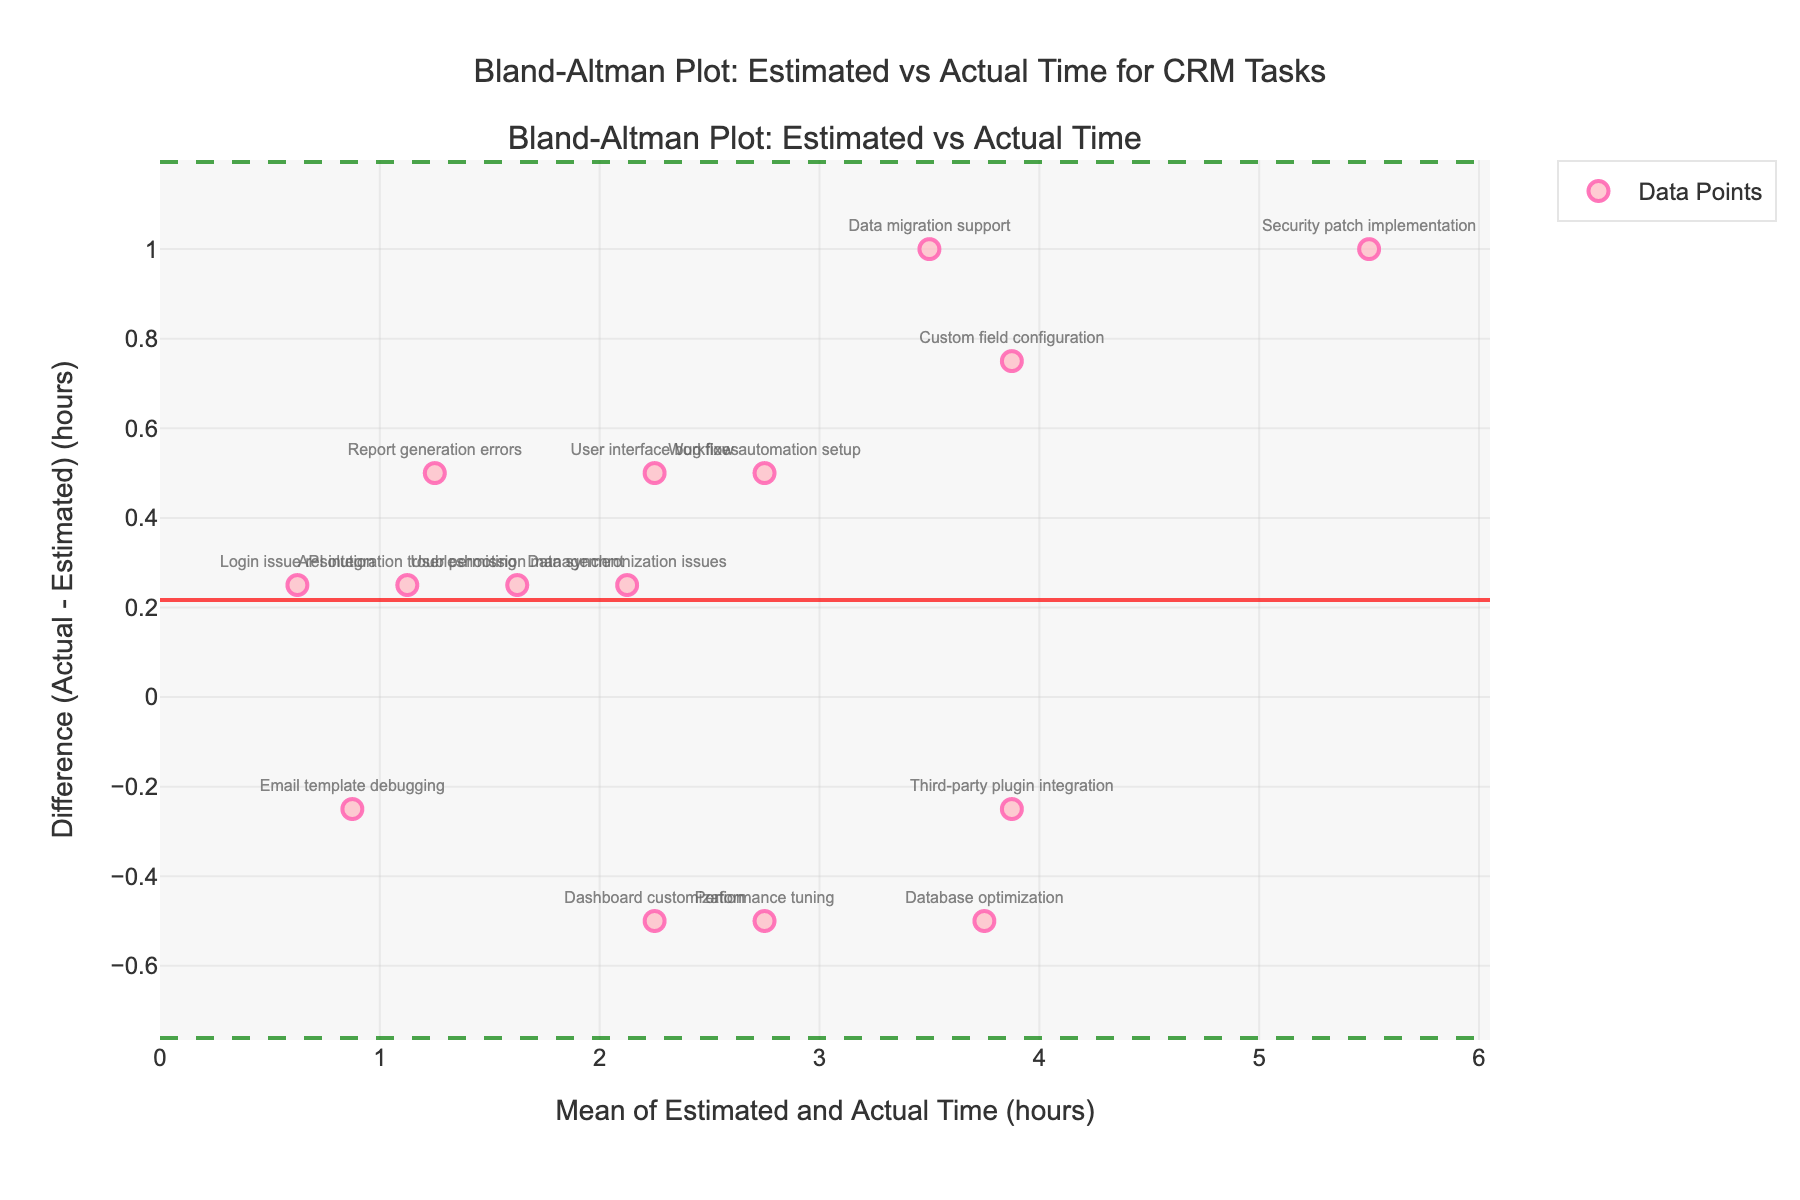What is the title of the figure? The title of the figure is generally found at the top and describes the content of the plot. Here, it is displayed clearly.
Answer: Bland-Altman Plot: Estimated vs Actual Time How many data points are represented in the plot? This can be observed by counting the number of markers on the plot. Each marker represents one data point.
Answer: 15 What do the horizontal lines on the plot represent? There are three horizontal lines that represent different statistical measurements. The solid red line represents the mean difference, while the dashed green lines represent the upper and lower limits of agreement.
Answer: Mean difference and limits of agreement What is the approximate mean difference (Actual - Estimated) based on the plot? The mean difference is represented by the solid red horizontal line on the plot. By looking at the y-axis value where this line is placed, we can approximate it.
Answer: Around 0.46 hours Which task has the largest positive difference between Actual and Estimated time? Identify which marker is highest above the mean difference line. By hovering or looking at the label near this marker, we can determine the task.
Answer: Security patch implementation Are there any tasks where the Estimated time was greater than Actual time? Check for any markers below the zero line on the plot. These represent tasks where the Actual time was less than the Estimated time.
Answer: Yes What is the range of the x-axis values? The x-axis represents the mean of the Estimated and Actual time. Look at the starting and ending values on the x-axis to determine the range.
Answer: 0 to around 4.4 hours How many tasks have a difference (Actual - Estimated) greater than 1 hour? Identify the number of markers that are above the 1-hour mark on the y-axis. These represent points with a difference greater than 1 hour.
Answer: 3 tasks For the task "Email template debugging", what is the difference between Actual and Estimated time? Find the marker labeled "Email template debugging" and check the y-axis value of this marker.
Answer: -0.25 hours Are there more tasks above or below the mean difference line? Count the number of markers above and below the solid red mean difference line. Compare the counts to determine which is more.
Answer: Above 